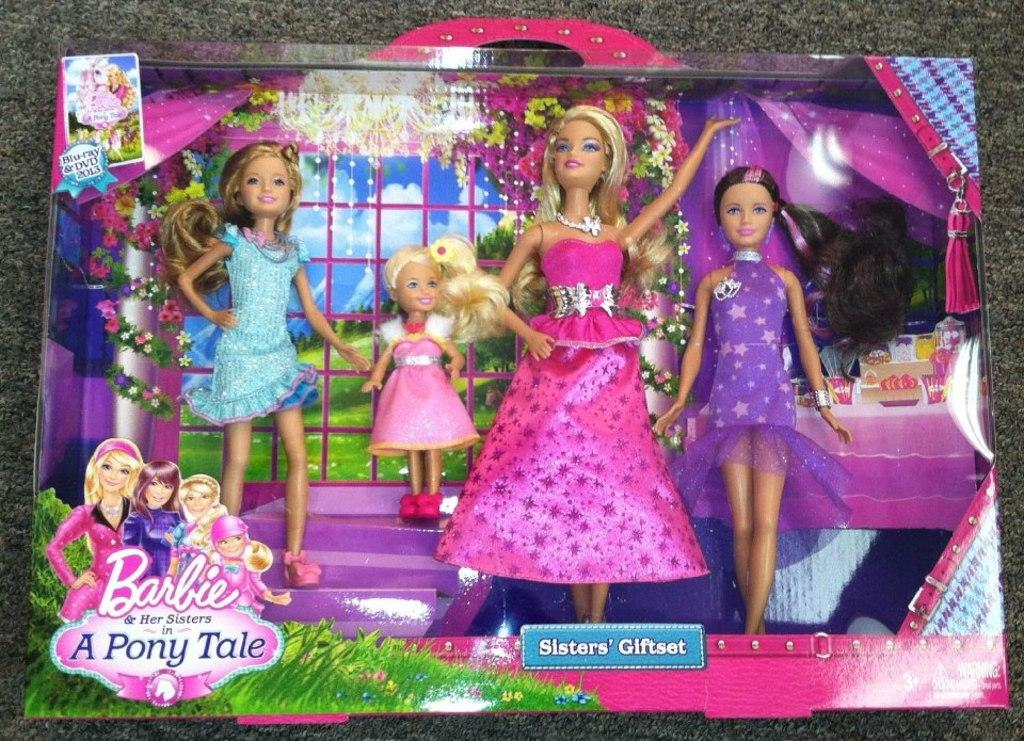What type of dolls are in the image? There are Barbie dolls in the image. Where are the Barbie dolls located? The Barbie dolls are in a box. What is at the bottom of the image? There is a mat at the bottom of the image. On what surface is the mat placed? The mat is on a surface. What type of debt is associated with the Barbie dolls in the image? There is no mention of debt in the image, and the Barbie dolls are not associated with any financial obligations. 